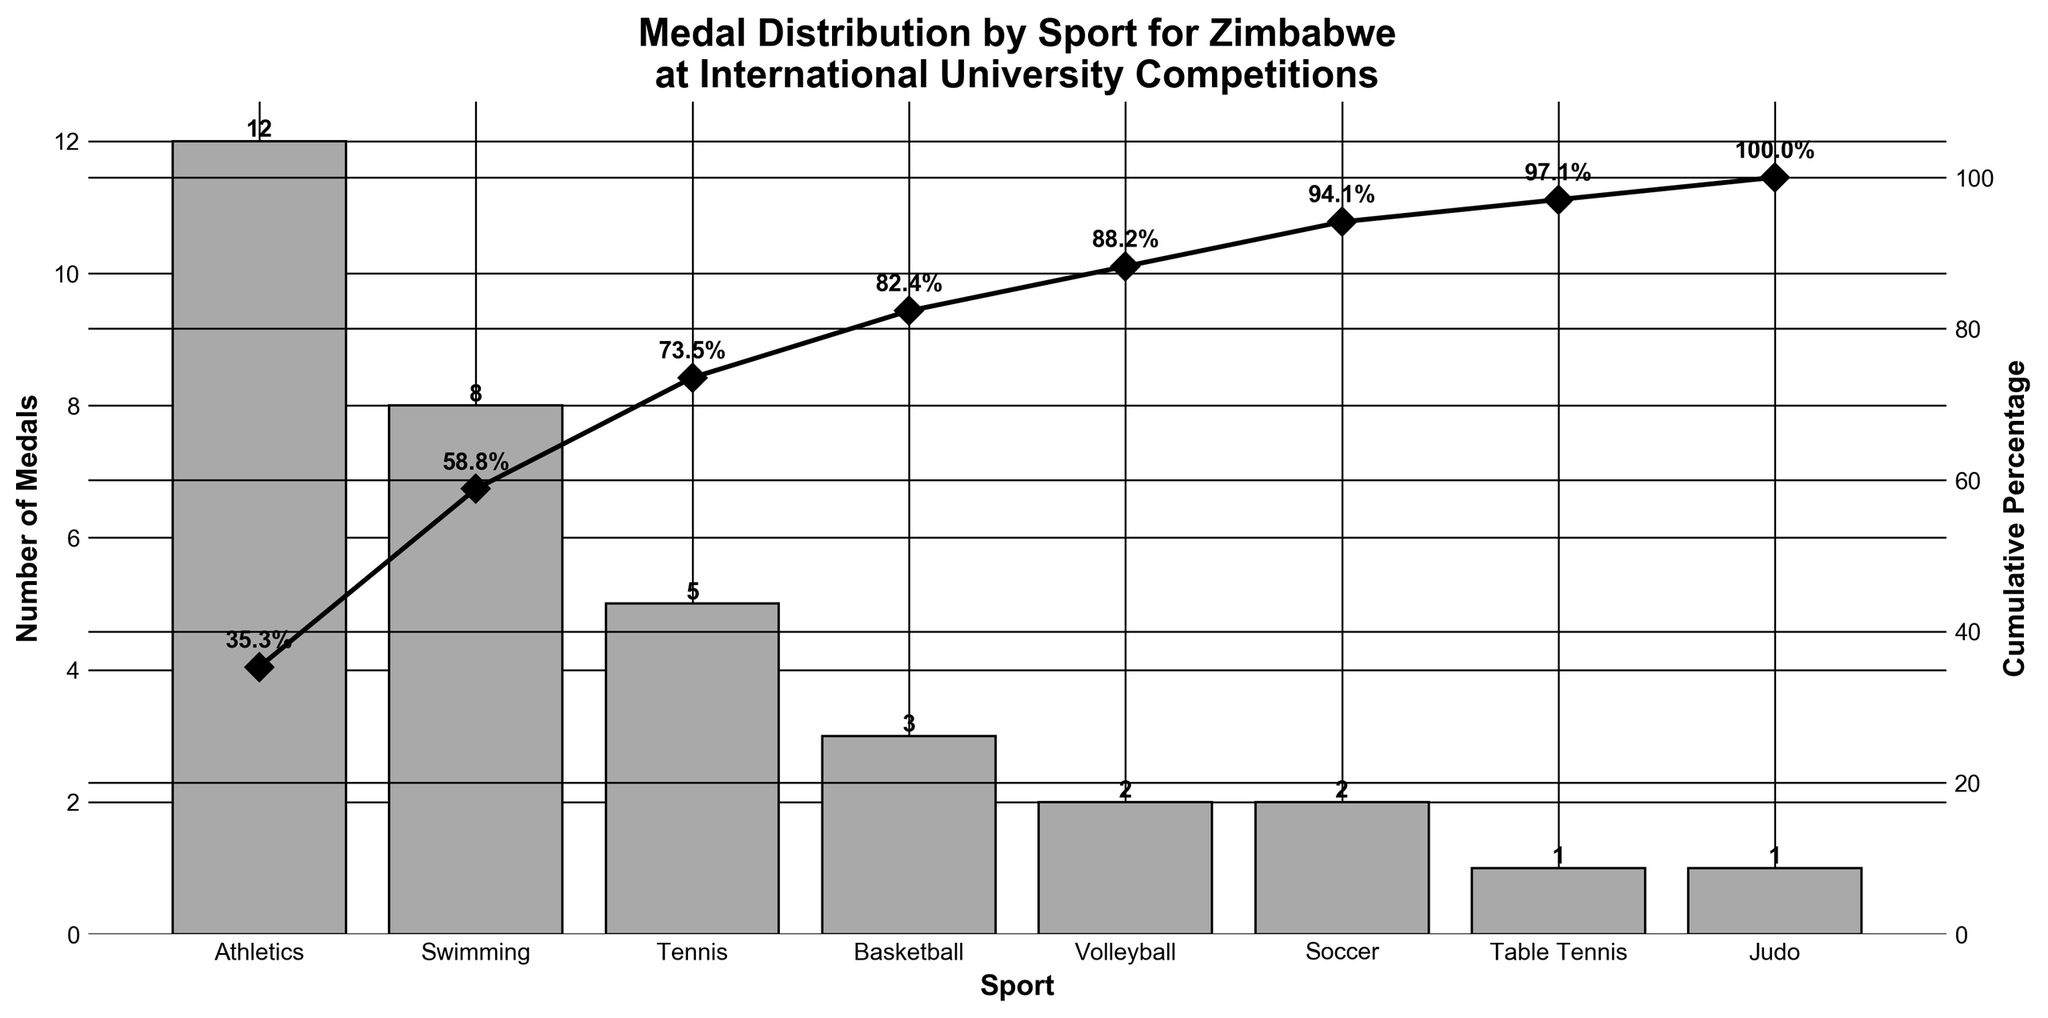What is the total number of medals won by Zimbabwe across all sports? By summing the values of all the bars representing each sport in the chart, we get 12 (Athletics) + 8 (Swimming) + 5 (Tennis) + 3 (Basketball) + 2 (Volleyball) + 2 (Soccer) + 1 (Table Tennis) + 1 (Judo) = 34.
Answer: 34 Which sport has the highest number of medals? Identify the tallest bar on the chart; it represents Athletics with 12 medals.
Answer: Athletics What is the cumulative percentage of medals after including Tennis? The cumulative percentage at Tennis includes the medals from Athletics, Swimming, and Tennis. Calculate (12 + 8 + 5) / 34 * 100 = 25 / 34 * 100 = 73.5%.
Answer: 73.5% How many more medals did Athletics win compared to Basketball? From the chart, Athletics won 12 medals, and Basketball won 3 medals. Subtract 3 from 12 to find the difference 12 - 3 = 9.
Answer: 9 What percentage of total medals does Table Tennis contribute? Table Tennis has 1 medal. The total number of medals is 34. So, (1 / 34) * 100 = 2.94%.
Answer: 2.94% What is the median number of medals won per sport? Arrange the medals in ascending order [1, 1, 2, 2, 3, 5, 8, 12]. The median is the average of the 4th and 5th values, which are 2 and 3. (2 + 3) / 2 = 2.5.
Answer: 2.5 Between Soccer and Volleyball, which sport won more medals? Compare the heights of the bars for Soccer and Volleyball. Volleyball is taller with 2 medals, while Soccer also has 2 medals.
Answer: Equal What is the title of the chart? Read the title located at the top of the chart, which states "Medal Distribution by Sport for Zimbabwe at International University Competitions".
Answer: Medal Distribution by Sport for Zimbabwe at International University Competitions What percentage of medals is accumulated by the top three sports? The cumulative percentage line at the third sport (Tennis) shows 73.5%, indicating the top three sports (Athletics, Swimming, Tennis) account for 73.5% of the total medals.
Answer: 73.5% Which sports individually contribute less than 5% to the total medals? Identify bars with medals less than 5% of the total 34, that is (5% of 34 is 1.7). Sports with medals less than 1.7 are Table Tennis and Judo, each contributing 1. So, they are less than 5%.
Answer: Table Tennis, Judo 